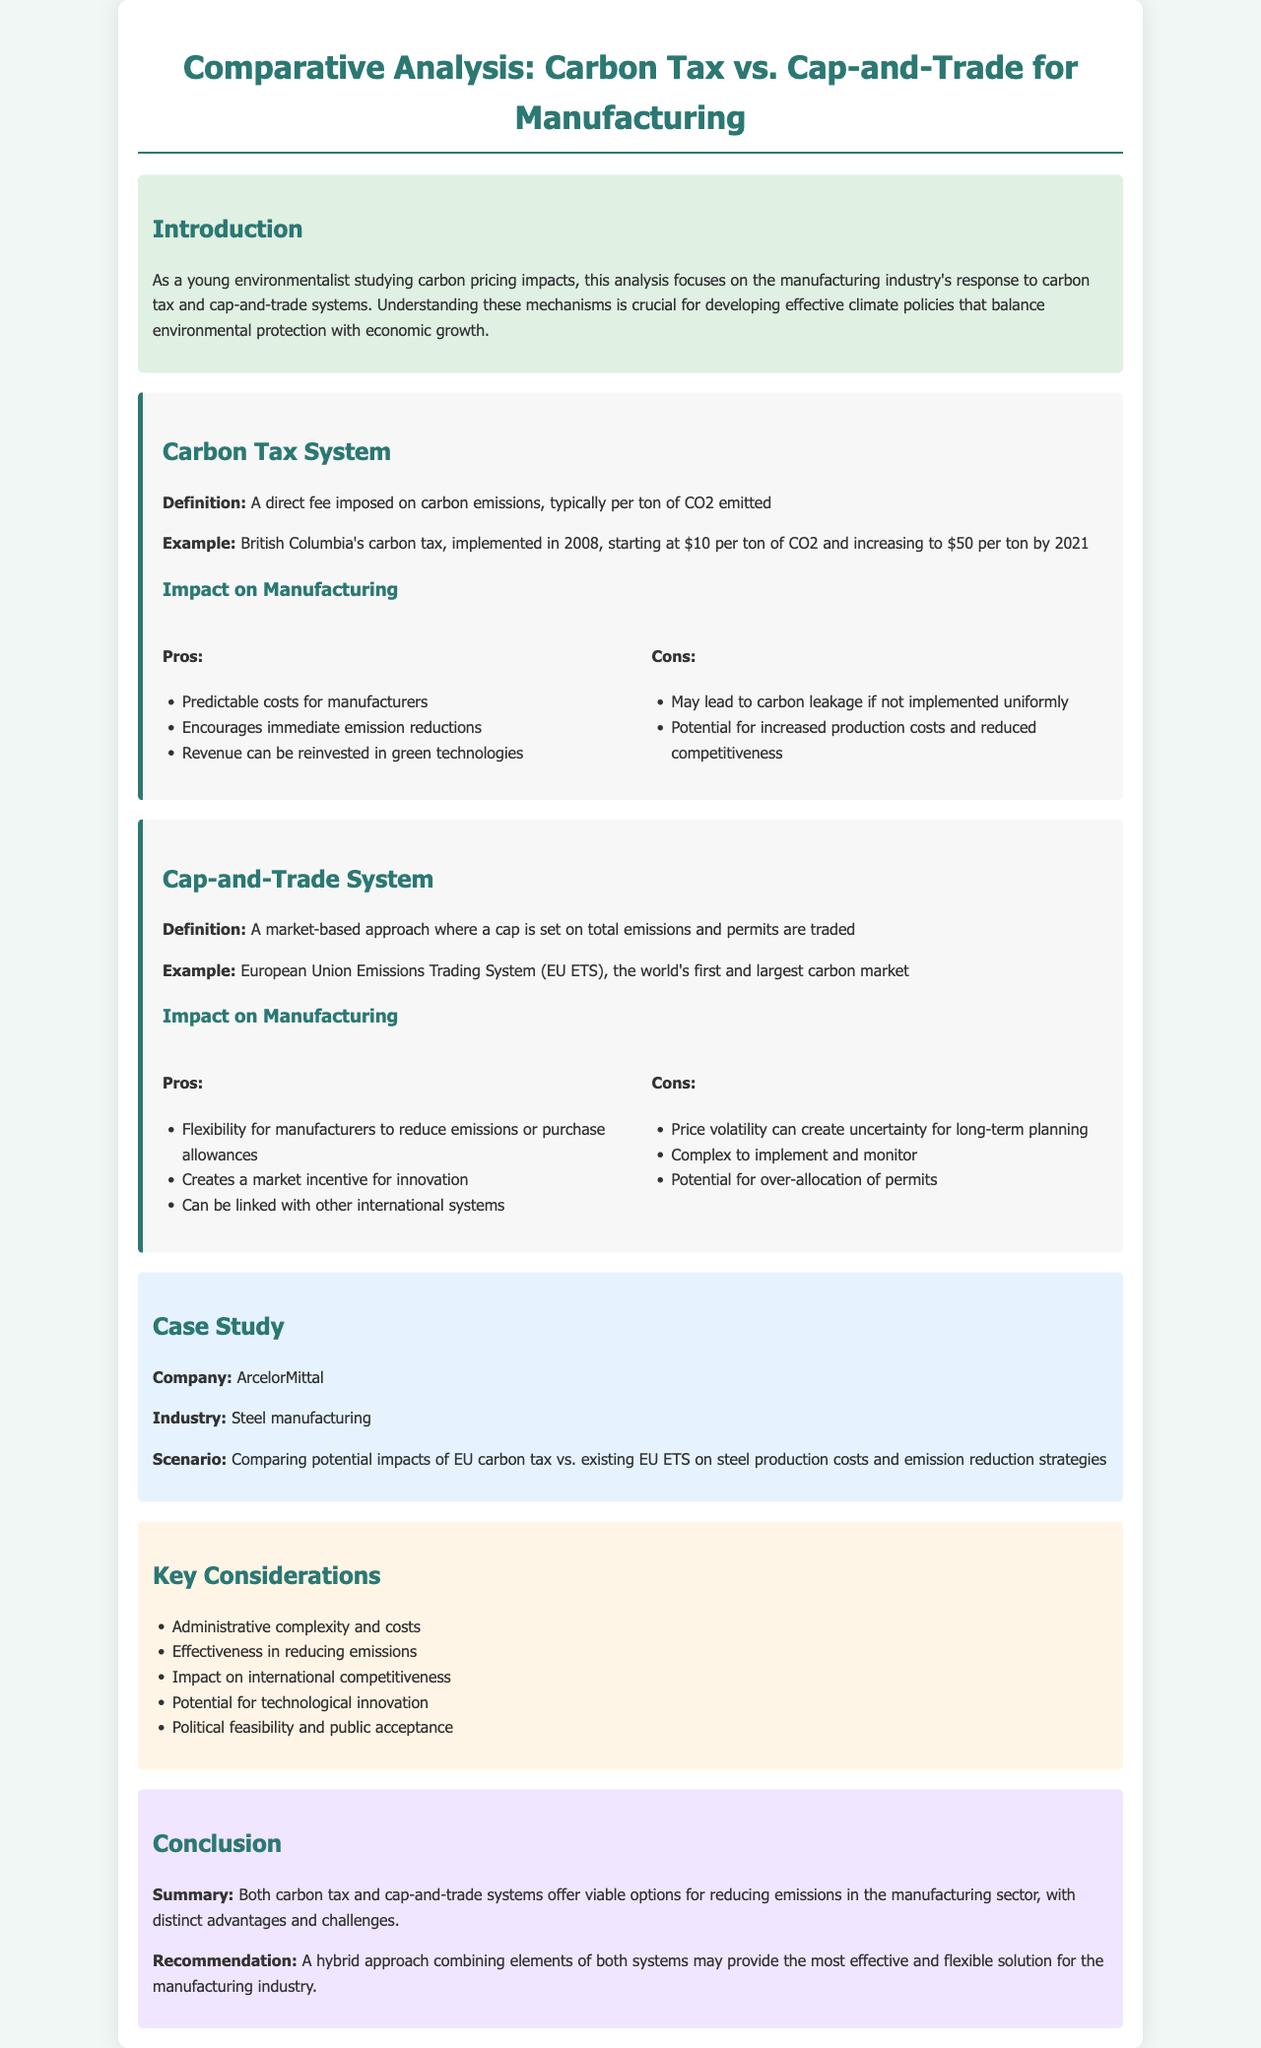What is the starting carbon tax in British Columbia? The document states that the British Columbia carbon tax started at $10 per ton of CO2 in 2008.
Answer: $10 What is a significant pro of the carbon tax system? A pro of the carbon tax system mentioned in the document is that it encourages immediate emission reductions.
Answer: Encourages immediate emission reductions What is a major con of the cap-and-trade system? The document highlights price volatility as a significant con of the cap-and-trade system, creating uncertainty for long-term planning.
Answer: Price volatility Which company is used as a case study in the document? The case study in the document focuses on ArcelorMittal.
Answer: ArcelorMittal What is one key consideration mentioned in the document regarding carbon pricing? The document lists "Impact on international competitiveness" as one of the key considerations.
Answer: Impact on international competitiveness What is the maximum carbon tax in British Columbia by 2021? The document specifies that the carbon tax increased to $50 per ton of CO2 by 2021.
Answer: $50 What does the conclusion suggest as a potential approach? The conclusion recommends a hybrid approach combining elements of both carbon tax and cap-and-trade systems.
Answer: Hybrid approach What is a key feature of the cap-and-trade system? The document defines that a key feature of the cap-and-trade system is that permits are traded.
Answer: Permits are traded What system is the world's first and largest carbon market? The European Union Emissions Trading System (EU ETS) is mentioned as the world's first and largest carbon market.
Answer: EU ETS 